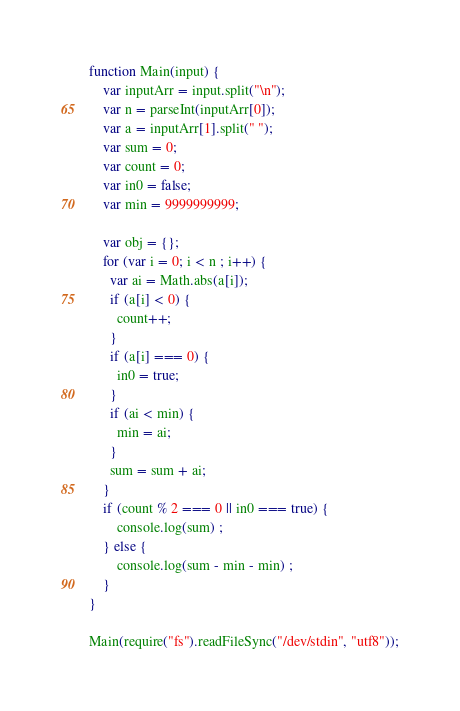Convert code to text. <code><loc_0><loc_0><loc_500><loc_500><_JavaScript_>function Main(input) {
	var inputArr = input.split("\n");
	var n = parseInt(inputArr[0]);
	var a = inputArr[1].split(" ");
    var sum = 0;
    var count = 0;
    var in0 = false;
    var min = 9999999999;
  
    var obj = {};
	for (var i = 0; i < n ; i++) {
      var ai = Math.abs(a[i]);
      if (a[i] < 0) {
        count++;
      }
      if (a[i] === 0) {
        in0 = true;
      }
      if (ai < min) {
        min = ai;
      }
      sum = sum + ai;
    }
    if (count % 2 === 0 || in0 === true) {
        console.log(sum) ;
    } else {
        console.log(sum - min - min) ;
    }
}

Main(require("fs").readFileSync("/dev/stdin", "utf8"));

</code> 